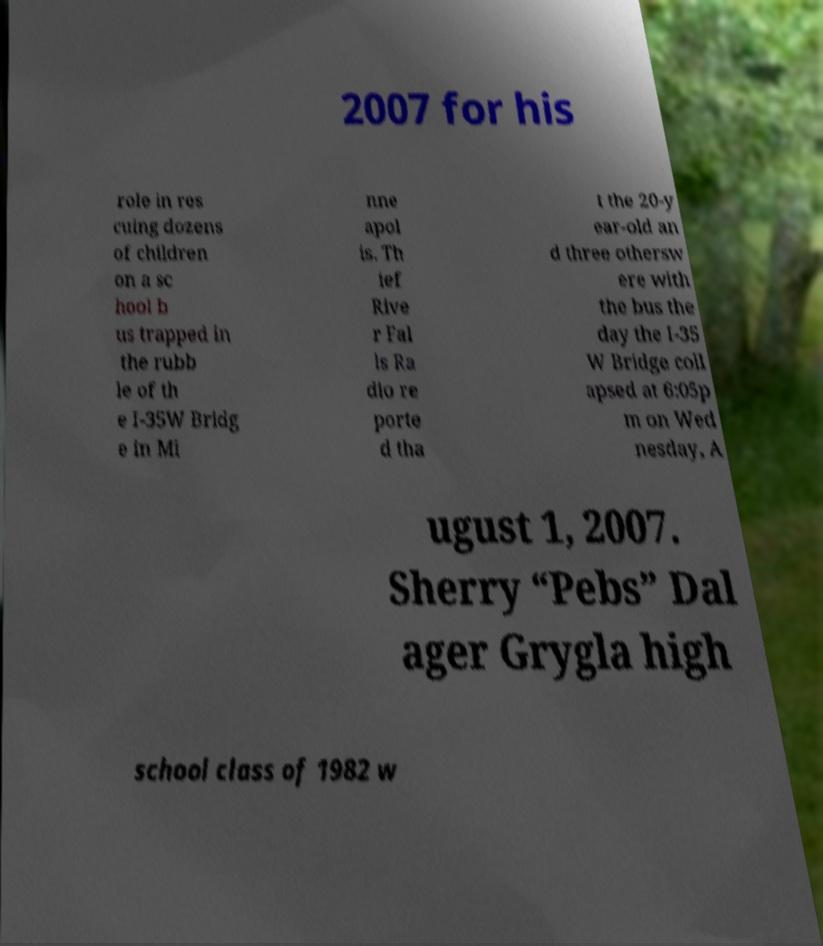There's text embedded in this image that I need extracted. Can you transcribe it verbatim? 2007 for his role in res cuing dozens of children on a sc hool b us trapped in the rubb le of th e I-35W Bridg e in Mi nne apol is. Th ief Rive r Fal ls Ra dio re porte d tha t the 20-y ear-old an d three othersw ere with the bus the day the I-35 W Bridge coll apsed at 6:05p m on Wed nesday, A ugust 1, 2007. Sherry “Pebs” Dal ager Grygla high school class of 1982 w 